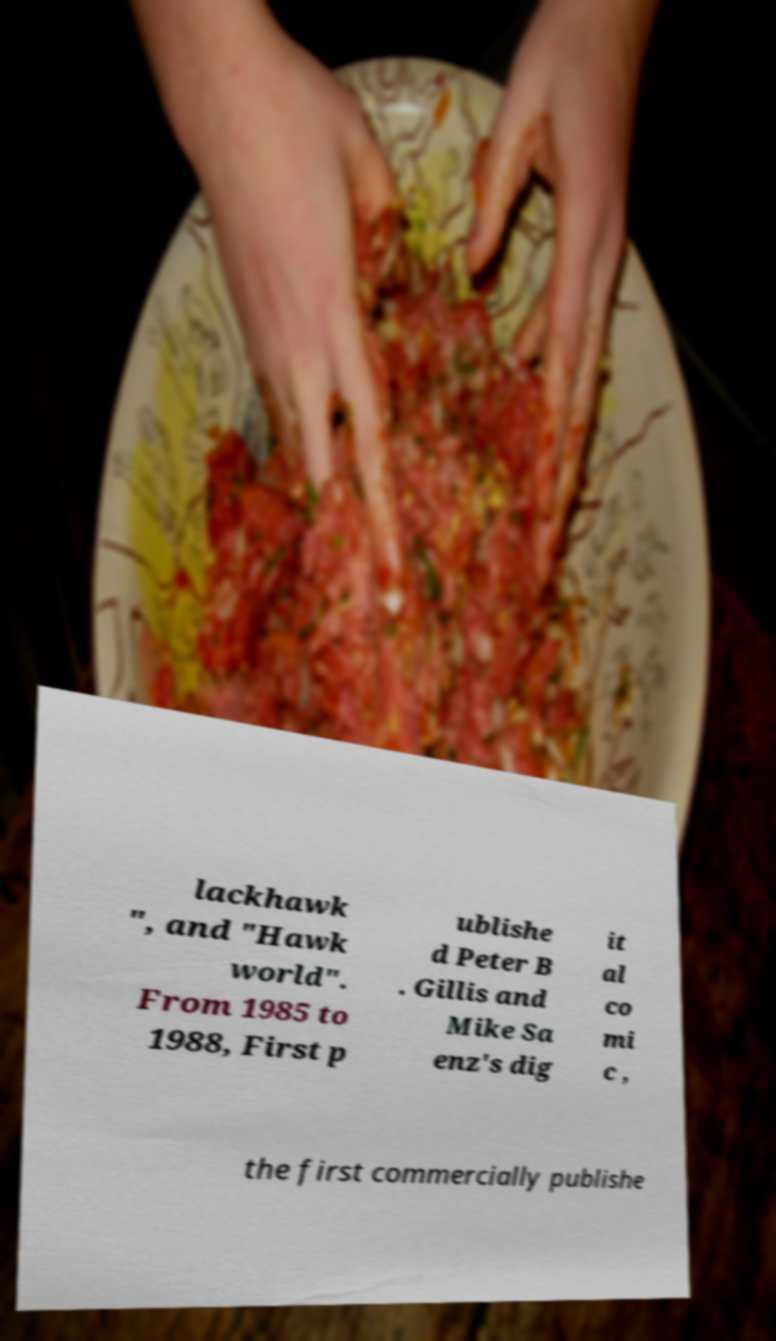I need the written content from this picture converted into text. Can you do that? lackhawk ", and "Hawk world". From 1985 to 1988, First p ublishe d Peter B . Gillis and Mike Sa enz's dig it al co mi c , the first commercially publishe 